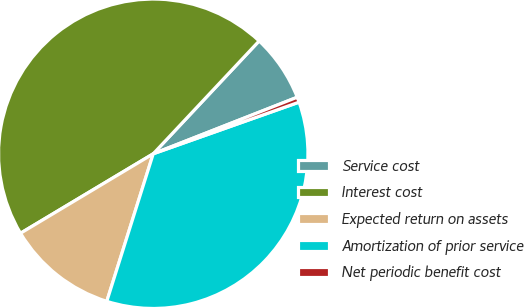Convert chart. <chart><loc_0><loc_0><loc_500><loc_500><pie_chart><fcel>Service cost<fcel>Interest cost<fcel>Expected return on assets<fcel>Amortization of prior service<fcel>Net periodic benefit cost<nl><fcel>7.05%<fcel>45.58%<fcel>11.56%<fcel>35.27%<fcel>0.54%<nl></chart> 